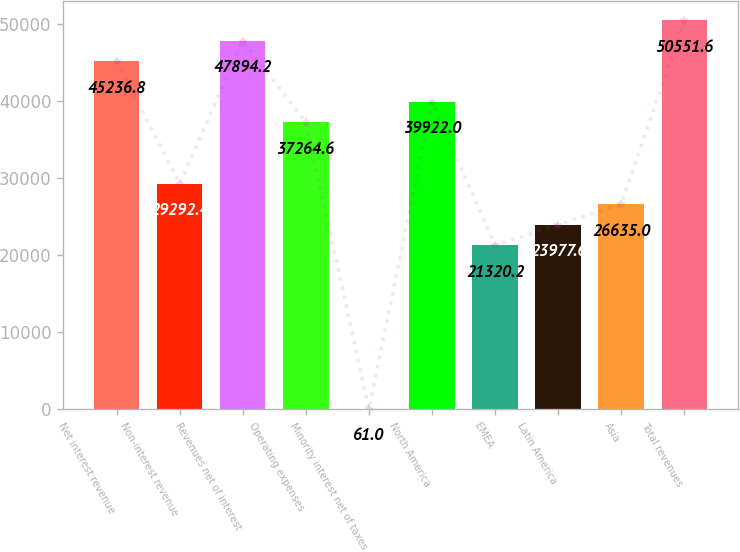Convert chart to OTSL. <chart><loc_0><loc_0><loc_500><loc_500><bar_chart><fcel>Net interest revenue<fcel>Non-interest revenue<fcel>Revenues net of interest<fcel>Operating expenses<fcel>Minority interest net of taxes<fcel>North America<fcel>EMEA<fcel>Latin America<fcel>Asia<fcel>Total revenues<nl><fcel>45236.8<fcel>29292.4<fcel>47894.2<fcel>37264.6<fcel>61<fcel>39922<fcel>21320.2<fcel>23977.6<fcel>26635<fcel>50551.6<nl></chart> 